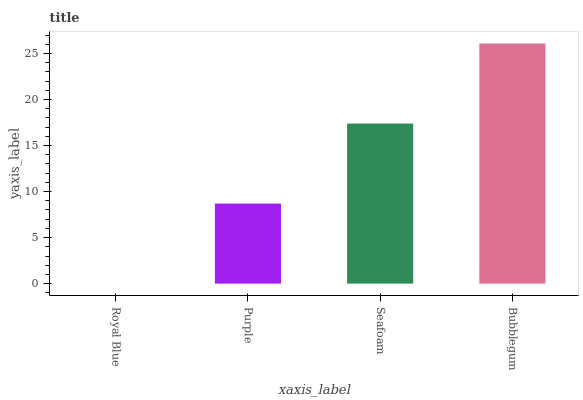Is Purple the minimum?
Answer yes or no. No. Is Purple the maximum?
Answer yes or no. No. Is Purple greater than Royal Blue?
Answer yes or no. Yes. Is Royal Blue less than Purple?
Answer yes or no. Yes. Is Royal Blue greater than Purple?
Answer yes or no. No. Is Purple less than Royal Blue?
Answer yes or no. No. Is Seafoam the high median?
Answer yes or no. Yes. Is Purple the low median?
Answer yes or no. Yes. Is Purple the high median?
Answer yes or no. No. Is Seafoam the low median?
Answer yes or no. No. 